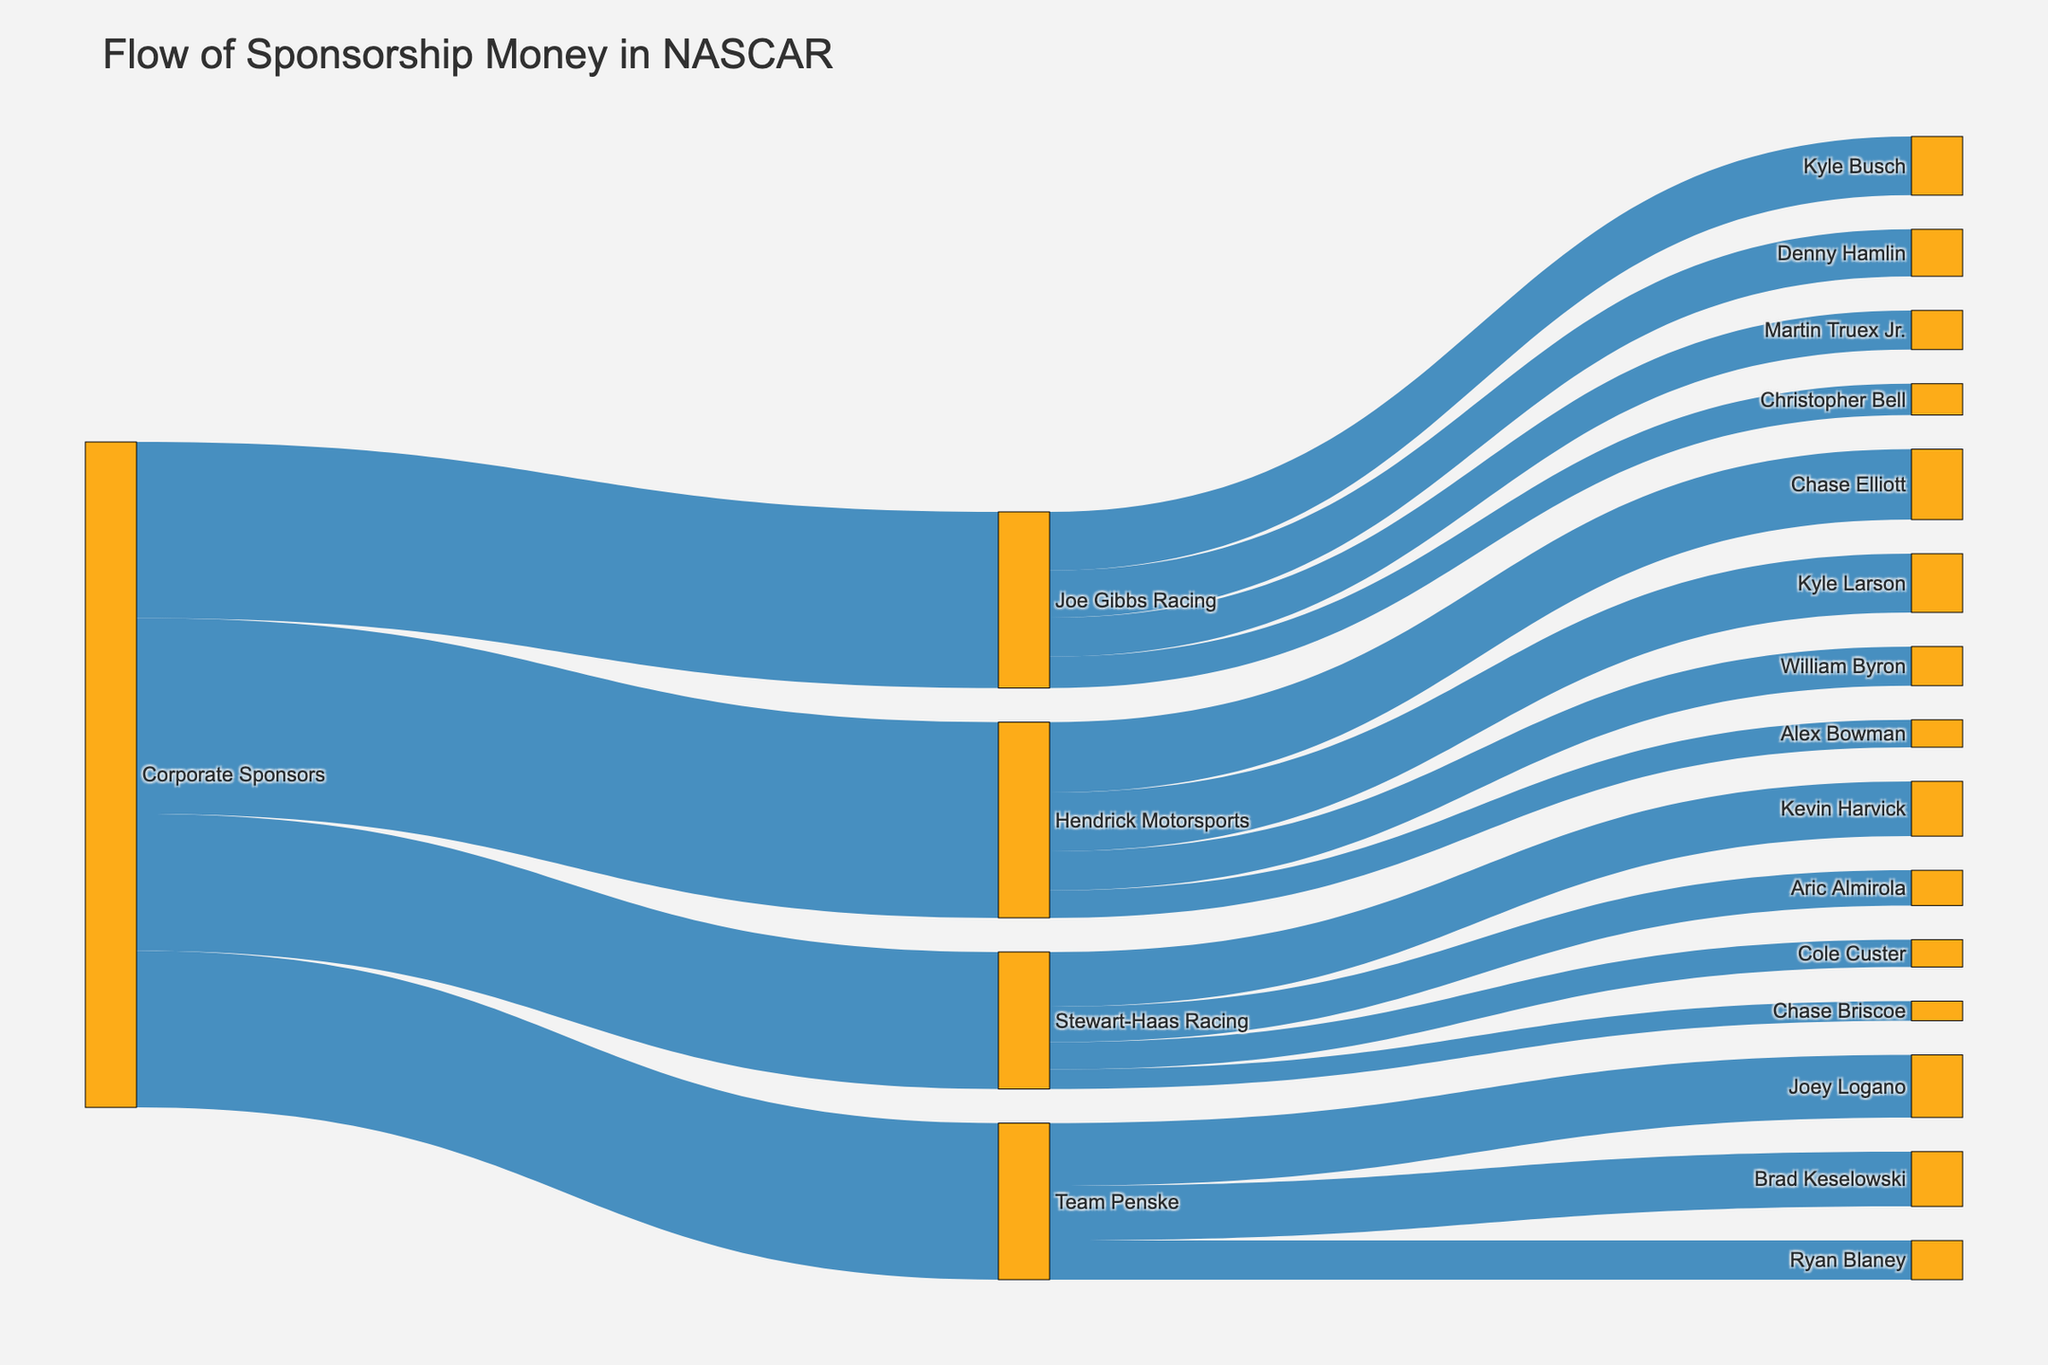How much money does Joe Gibbs Racing receive in total from corporate sponsors? Sum the values from Corporate Sponsors to Joe Gibbs Racing: 45
Answer: 45 Which team receives the highest sponsorship money from corporate sponsors? Compare the sponsorship amounts: Joe Gibbs Racing (45), Hendrick Motorsports (50), Stewart-Haas Racing (35), Team Penske (40); Hendrick Motorsports receives the highest amount, 50
Answer: Hendrick Motorsports How much money does Kyle Busch receive from Joe Gibbs Racing? Refer to the flow from Joe Gibbs Racing to Kyle Busch: 15
Answer: 15 Who receives more sponsorship money, Martin Truex Jr. or Brad Keselowski? Compare the sponsorship amounts: Martin Truex Jr. (10), Brad Keselowski (14); Brad Keselowski receives more
Answer: Brad Keselowski What is the sum of sponsorship money received by all drivers in Team Penske? Sum the values from Team Penske to Joey Logano (16), Brad Keselowski (14), Ryan Blaney (10); 16 + 14 + 10 = 40
Answer: 40 Which driver in Hendrick Motorsports receives the least amount of sponsorship money? Compare the values: Chase Elliott (18), Kyle Larson (15), William Byron (10), Alex Bowman (7); Alex Bowman receives the least, 7
Answer: Alex Bowman What is the total sponsorship amount distributed by Stewart-Haas Racing to its drivers? Sum the values from Stewart-Haas Racing: Kevin Harvick (14), Aric Almirola (9), Cole Custer (7), Chase Briscoe (5); 14 + 9 + 7 + 5 = 35
Answer: 35 Which driver receives the highest sponsorship within their respective team? Compare values within teams; Joe Gibbs Racing (Kyle Busch 15), Hendrick Motorsports (Chase Elliott 18), Stewart-Haas Racing (Kevin Harvick 14), Team Penske (Joey Logano 16); highest individual is Chase Elliott 18
Answer: Chase Elliott How much more money does Chase Elliott receive compared to Cole Custer? Compare the values: Chase Elliott (18), Cole Custer (7); 18 - 7 = 11
Answer: 11 